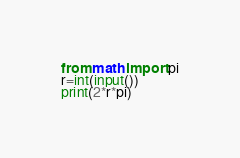Convert code to text. <code><loc_0><loc_0><loc_500><loc_500><_Python_>from math import pi
r=int(input())
print(2*r*pi)</code> 